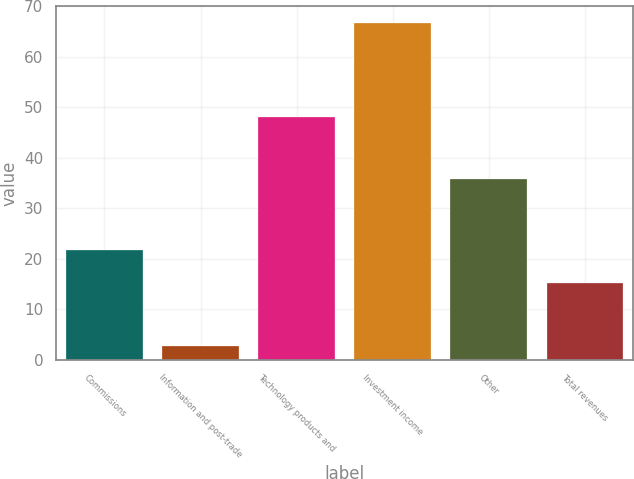Convert chart. <chart><loc_0><loc_0><loc_500><loc_500><bar_chart><fcel>Commissions<fcel>Information and post-trade<fcel>Technology products and<fcel>Investment income<fcel>Other<fcel>Total revenues<nl><fcel>21.7<fcel>2.7<fcel>48<fcel>66.7<fcel>35.8<fcel>15.3<nl></chart> 